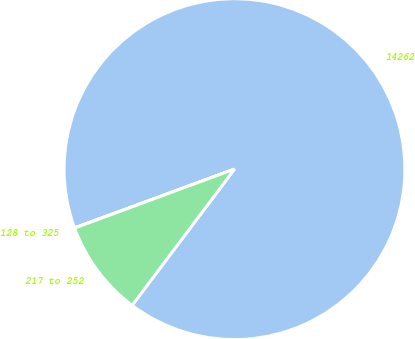<chart> <loc_0><loc_0><loc_500><loc_500><pie_chart><fcel>14262<fcel>128 to 325<fcel>217 to 252<nl><fcel>90.85%<fcel>0.03%<fcel>9.11%<nl></chart> 